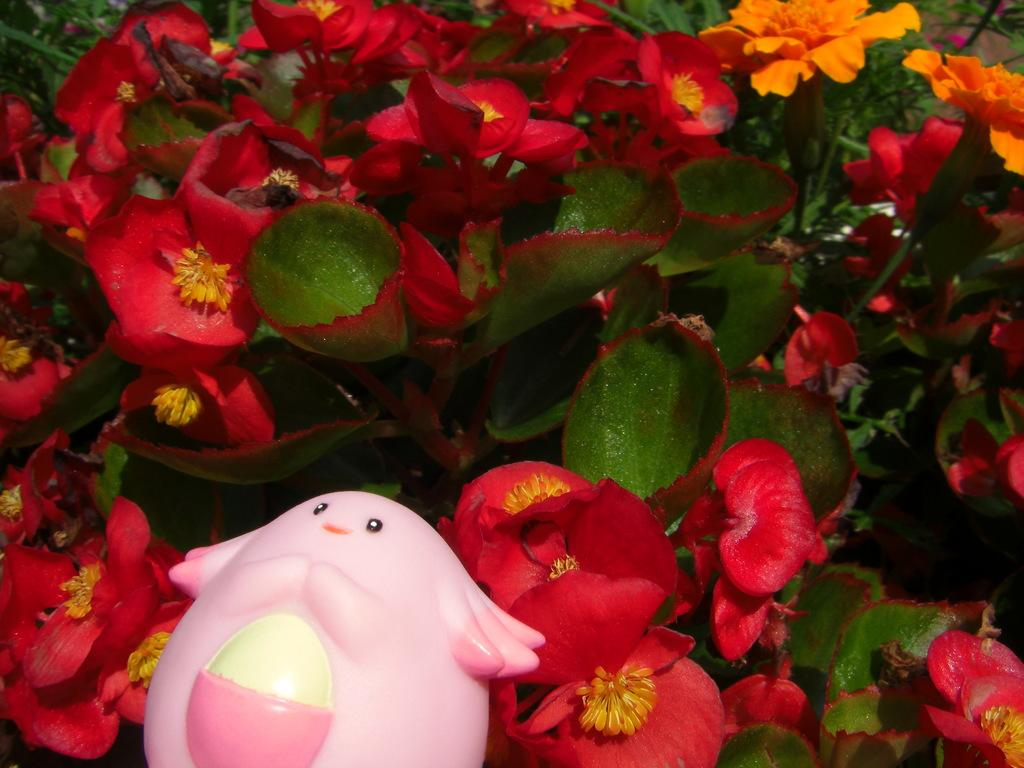What object can be seen in the image? There is a toy in the image. What colors are used for the toy? The toy is pink and white in color. What can be seen in the background of the image? There are flowers and leaves in the background of the image. What colors are the flowers and leaves? The flowers are red in color, and the leaves are green in color. Is there a cat in jail in the image? No, there is no cat or jail present in the image. How many legs does the toy have in the image? The provided facts do not mention the number of legs on the toy, so it cannot be determined from the image. 